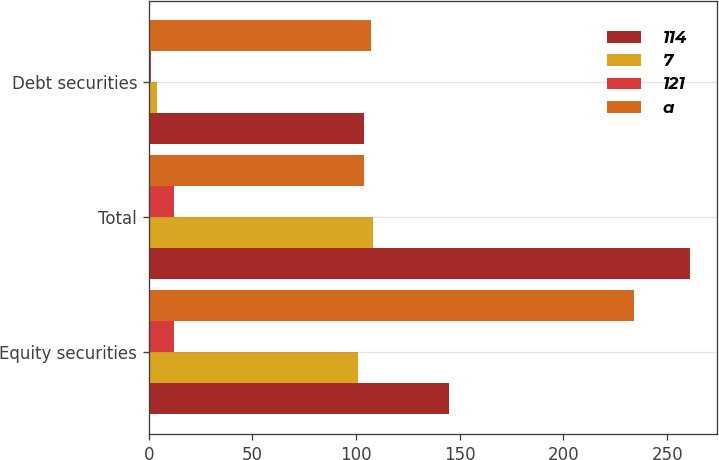Convert chart to OTSL. <chart><loc_0><loc_0><loc_500><loc_500><stacked_bar_chart><ecel><fcel>Equity securities<fcel>Total<fcel>Debt securities<nl><fcel>114<fcel>145<fcel>261<fcel>104<nl><fcel>7<fcel>101<fcel>108<fcel>4<nl><fcel>121<fcel>12<fcel>12<fcel>1<nl><fcel>a<fcel>234<fcel>104<fcel>107<nl></chart> 